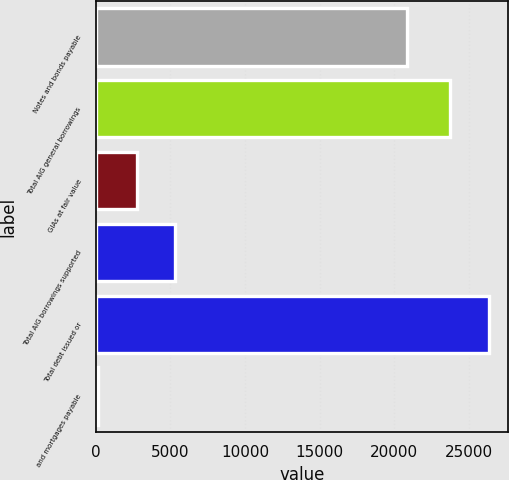<chart> <loc_0><loc_0><loc_500><loc_500><bar_chart><fcel>Notes and bonds payable<fcel>Total AIG general borrowings<fcel>GIAs at fair value<fcel>Total AIG borrowings supported<fcel>Total debt issued or<fcel>and mortgages payable<nl><fcel>20853<fcel>23734<fcel>2748<fcel>5328<fcel>26314<fcel>168<nl></chart> 